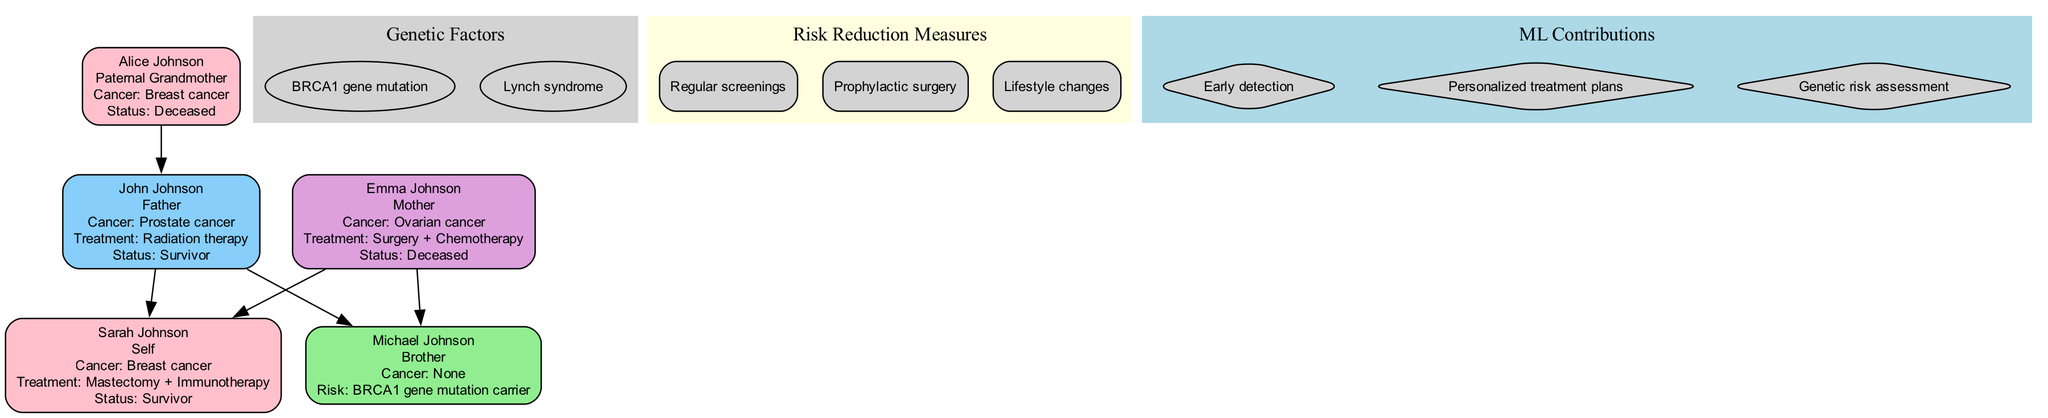What type of cancer did Sarah Johnson have? The diagram indicates that Sarah Johnson's cancer type is listed directly next to her name, specifically stating "Breast cancer."
Answer: Breast cancer How many members in the family have had cancer? By counting the individuals in the diagram that have a defined "cancer_type," we find that three members—Sarah, John, and Emma—experienced cancer.
Answer: Three What treatment did John Johnson undergo? The diagram provides information about John Johnson's treatment under his name, stating it was "Radiation therapy."
Answer: Radiation therapy Which family member is a BRCA1 gene mutation carrier? The diagram notes Michael Johnson's risk factor as "BRCA1 gene mutation carrier," which identifies him as the individual with this genetic risk factor.
Answer: Michael Johnson What is the relationship between Sarah Johnson and John Johnson? The diagram shows a direct edge connecting Sarah Johnson and John Johnson, implying a parent-child relationship, making John her father.
Answer: Father What genetic factor is most relevant to this family? The diagram highlights "BRCA1 gene mutation," which is listed as a genetic factor affecting family members, representing a significant inherited risk.
Answer: BRCA1 gene mutation How many nodes represent cancer treatments in the diagram? Each family member with cancer has their treatment detailed under their node, and there are three members (Sarah, John, and Emma) with treatments mentioned, thus there are three treatment nodes.
Answer: Three Which member is deceased? The diagram states Emma Johnson's status as "Deceased," indicating she is the family member who has passed away.
Answer: Emma Johnson What are two risk reduction measures mentioned? The diagram lists multiple risk reduction measures, among which "Regular screenings" and "Prophylactic surgery" are present, indicating effective strategies for reducing cancer risk.
Answer: Regular screenings, Prophylactic surgery 